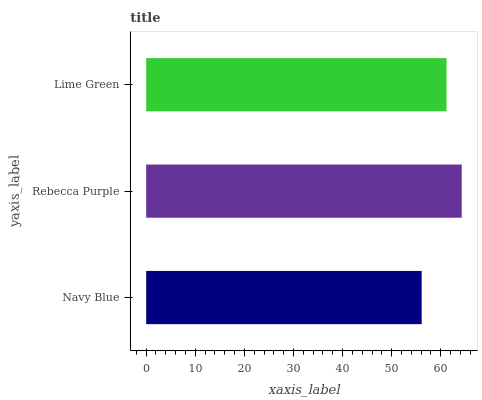Is Navy Blue the minimum?
Answer yes or no. Yes. Is Rebecca Purple the maximum?
Answer yes or no. Yes. Is Lime Green the minimum?
Answer yes or no. No. Is Lime Green the maximum?
Answer yes or no. No. Is Rebecca Purple greater than Lime Green?
Answer yes or no. Yes. Is Lime Green less than Rebecca Purple?
Answer yes or no. Yes. Is Lime Green greater than Rebecca Purple?
Answer yes or no. No. Is Rebecca Purple less than Lime Green?
Answer yes or no. No. Is Lime Green the high median?
Answer yes or no. Yes. Is Lime Green the low median?
Answer yes or no. Yes. Is Rebecca Purple the high median?
Answer yes or no. No. Is Navy Blue the low median?
Answer yes or no. No. 